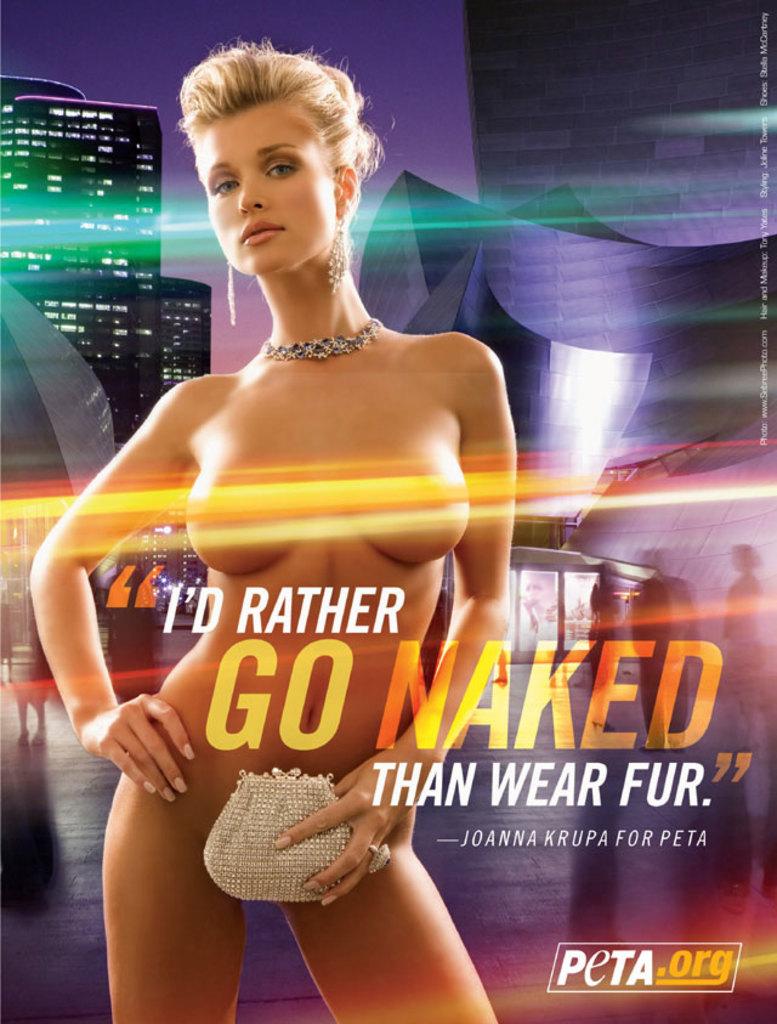Who is the person in the ad?
Give a very brief answer. Joanna krupa. 